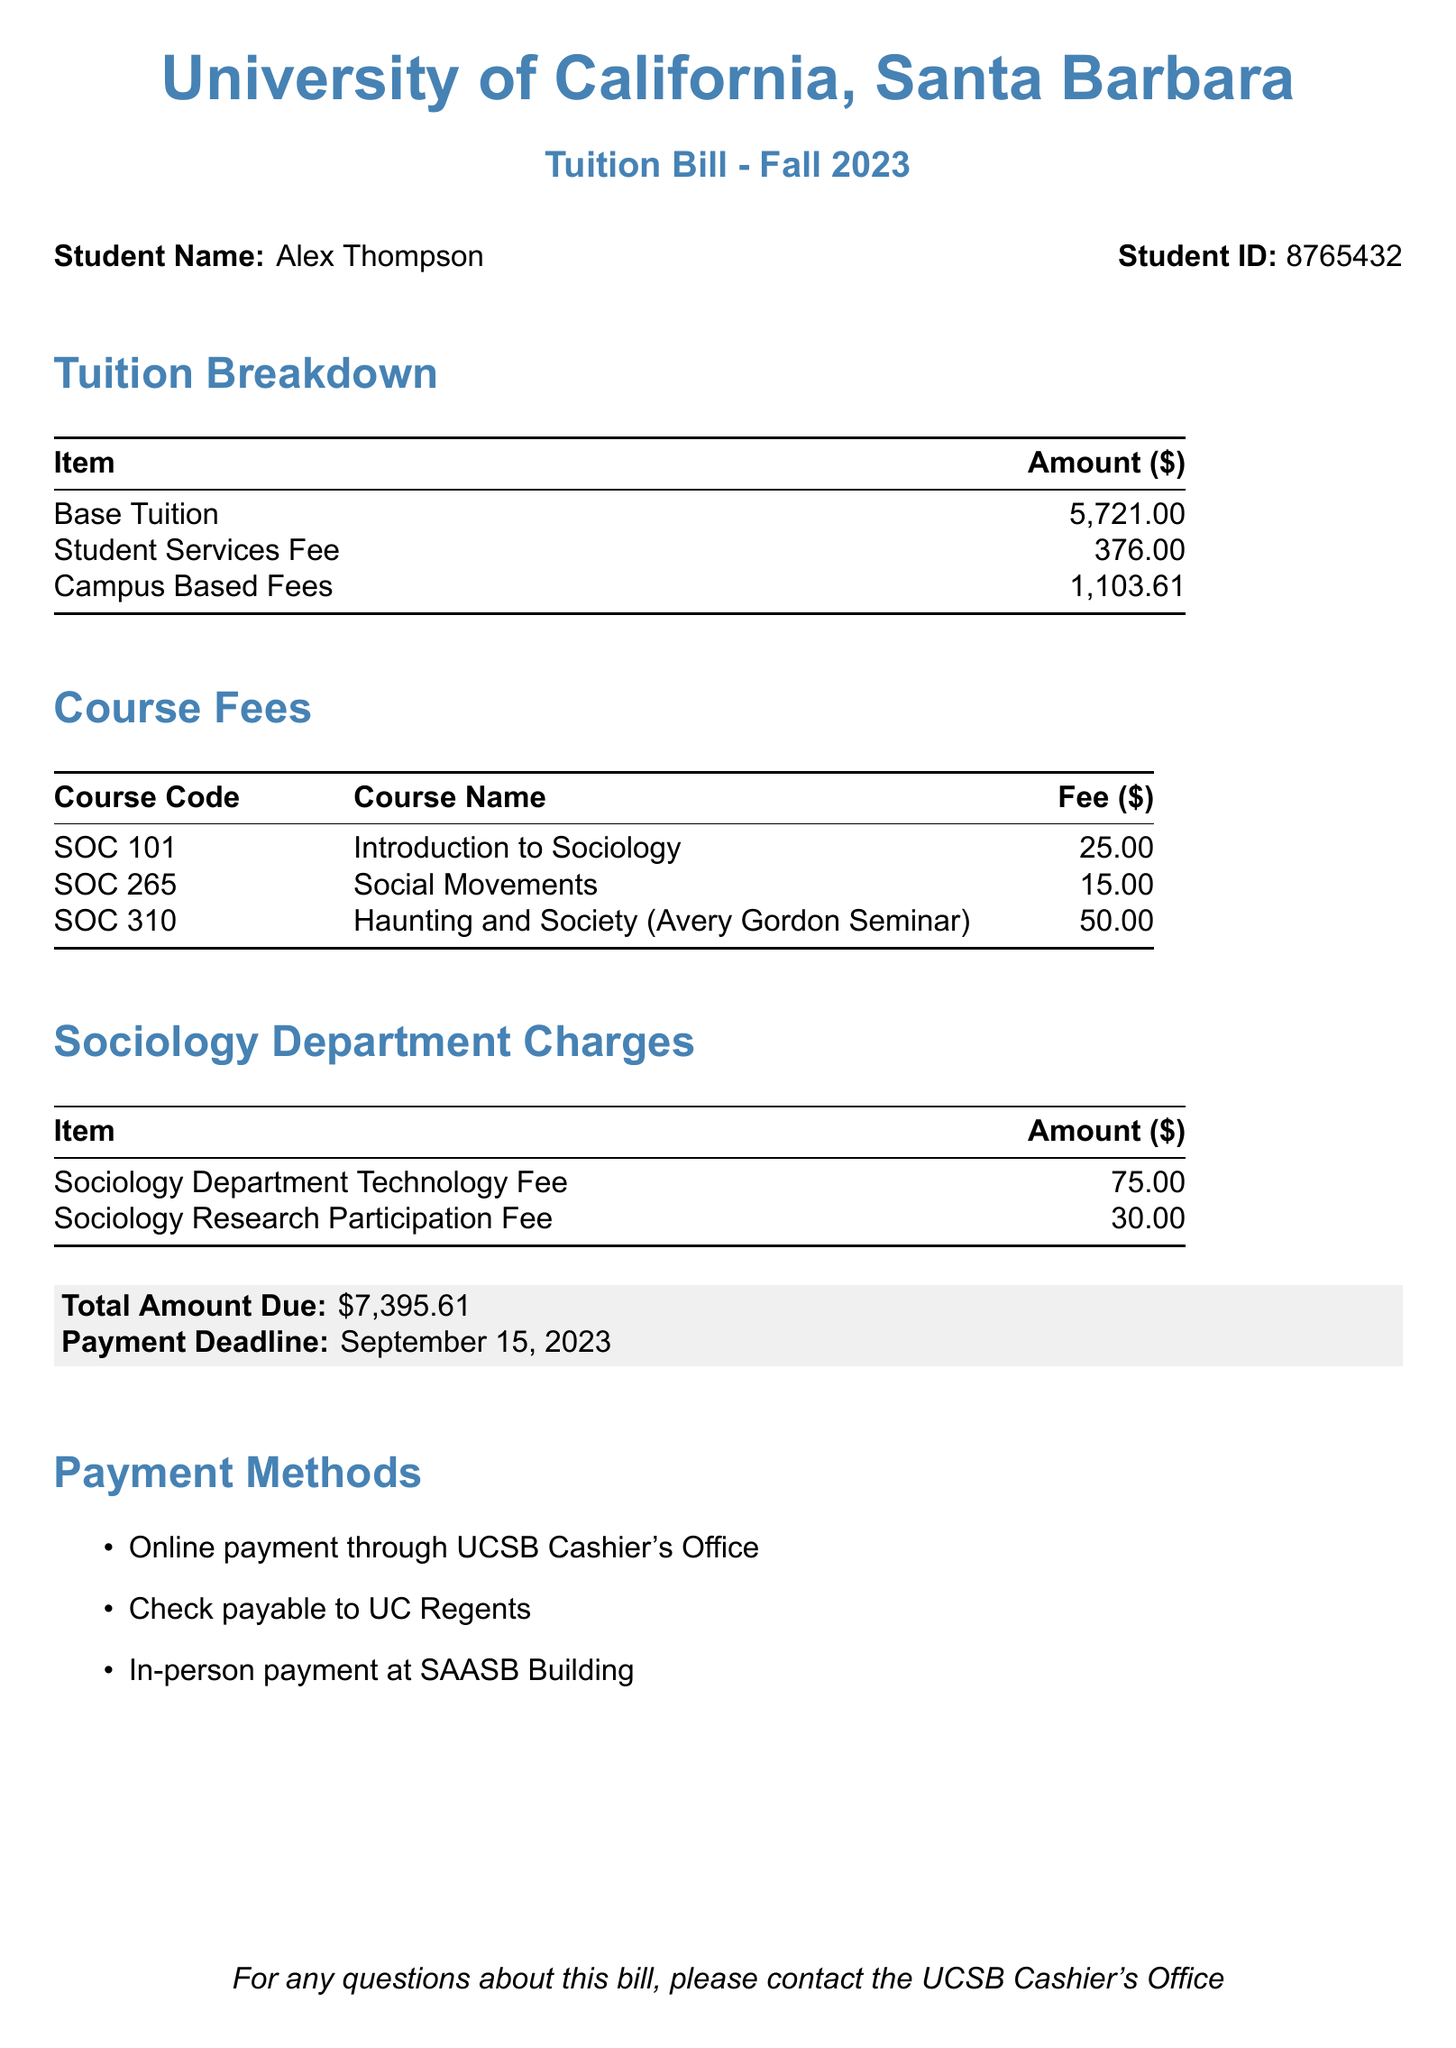What is the base tuition amount? The base tuition amount is specifically listed in the tuition breakdown section of the document.
Answer: 5,721.00 What is the fee for SOC 310? The fee for SOC 310 is provided in the course fees table within the document.
Answer: 50.00 What is the total amount due? The total amount due is highlighted at the bottom of the document, summarizing all charges.
Answer: 7,395.61 When is the payment deadline? The payment deadline is stated clearly in the document, next to the total amount due.
Answer: September 15, 2023 What types of payment methods are available? The document provides a list of payment methods available for the tuition bill.
Answer: Online payment, Check, In-person payment How much does the Sociology Research Participation Fee cost? The cost of the Sociology Research Participation Fee is detailed in the sociology department charges section.
Answer: 30.00 What seminar is associated with Avery Gordon? The seminar associated with Avery Gordon is specifically mentioned in the course fees section.
Answer: Haunting and Society (Avery Gordon Seminar) What are the Campus Based Fees total? The Campus Based Fees amount is included in the tuition breakdown section of the document.
Answer: 1,103.61 How much is the Sociology Department Technology Fee? The Sociology Department Technology Fee is listed in the sociology department charges section.
Answer: 75.00 